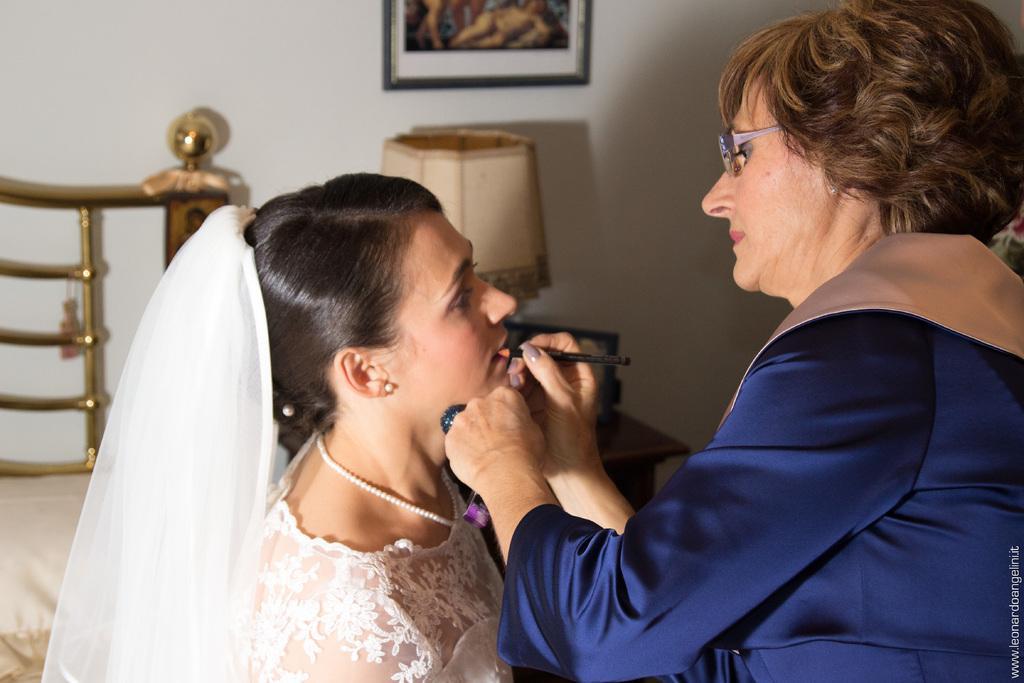Could you give a brief overview of what you see in this image? The woman wearing white dress is sitting and there is a make up artist in front of her and there are some other objects in the background. 